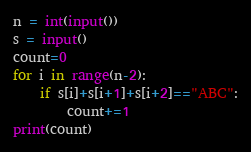Convert code to text. <code><loc_0><loc_0><loc_500><loc_500><_Python_>n = int(input())
s = input()
count=0
for i in range(n-2):
    if s[i]+s[i+1]+s[i+2]=="ABC":
        count+=1
print(count)</code> 